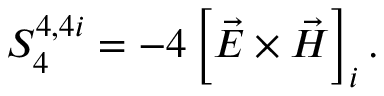<formula> <loc_0><loc_0><loc_500><loc_500>S _ { 4 } ^ { 4 , 4 i } = - 4 \left [ \vec { E } \times \vec { H } \right ] _ { i } .</formula> 